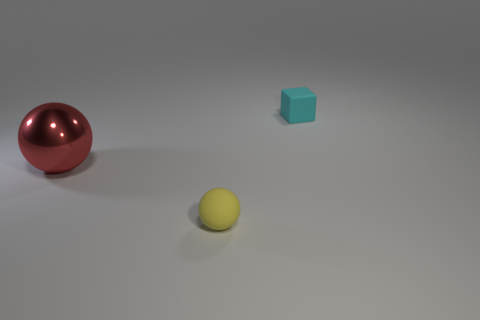Is the small yellow object made of the same material as the cube?
Ensure brevity in your answer.  Yes. What number of big metal balls are to the left of the object in front of the large red metallic ball in front of the cyan object?
Your answer should be very brief. 1. Are there any other yellow balls made of the same material as the small yellow ball?
Give a very brief answer. No. Are there fewer big balls than purple blocks?
Provide a succinct answer. No. What material is the large red object on the left side of the thing right of the ball that is in front of the red shiny ball?
Your answer should be compact. Metal. Is the number of cyan matte things to the left of the small yellow object less than the number of big red spheres?
Your answer should be very brief. Yes. There is a rubber thing on the right side of the yellow rubber sphere; does it have the same size as the yellow sphere?
Ensure brevity in your answer.  Yes. What number of things are behind the big thing and left of the yellow matte object?
Your answer should be very brief. 0. There is a sphere that is behind the small matte thing in front of the big object; how big is it?
Offer a very short reply. Large. Is the number of tiny balls that are behind the tiny cyan matte cube less than the number of cyan rubber blocks right of the yellow matte thing?
Provide a short and direct response. Yes. 